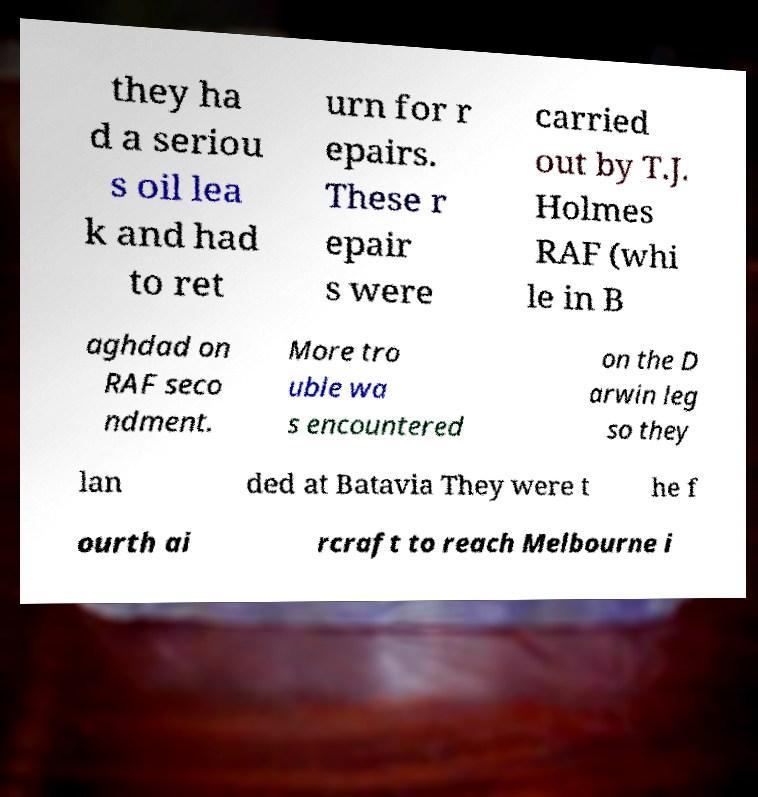What messages or text are displayed in this image? I need them in a readable, typed format. they ha d a seriou s oil lea k and had to ret urn for r epairs. These r epair s were carried out by T.J. Holmes RAF (whi le in B aghdad on RAF seco ndment. More tro uble wa s encountered on the D arwin leg so they lan ded at Batavia They were t he f ourth ai rcraft to reach Melbourne i 